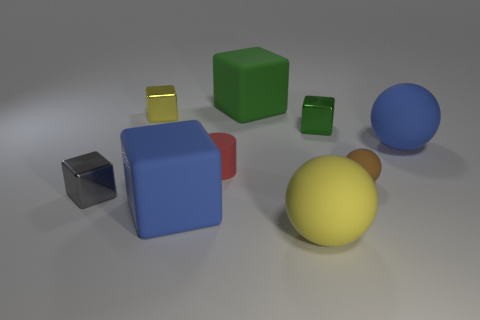Is the shape of the small red rubber thing the same as the gray object?
Your answer should be compact. No. How many big rubber blocks are in front of the small matte cylinder and behind the gray metal thing?
Offer a very short reply. 0. What number of things are green shiny objects or small cubes to the right of the big green matte thing?
Make the answer very short. 1. Are there more brown things than tiny blue balls?
Your answer should be very brief. Yes. The blue thing on the left side of the small brown rubber thing has what shape?
Make the answer very short. Cube. How many other tiny rubber things are the same shape as the brown matte object?
Provide a short and direct response. 0. What size is the blue rubber object that is behind the cylinder on the left side of the tiny brown thing?
Make the answer very short. Large. What number of brown things are metallic things or small cylinders?
Your response must be concise. 0. Are there fewer yellow rubber things behind the tiny gray metal object than big spheres behind the brown thing?
Your answer should be compact. Yes. There is a green shiny thing; does it have the same size as the metallic block that is on the left side of the yellow metal cube?
Keep it short and to the point. Yes. 